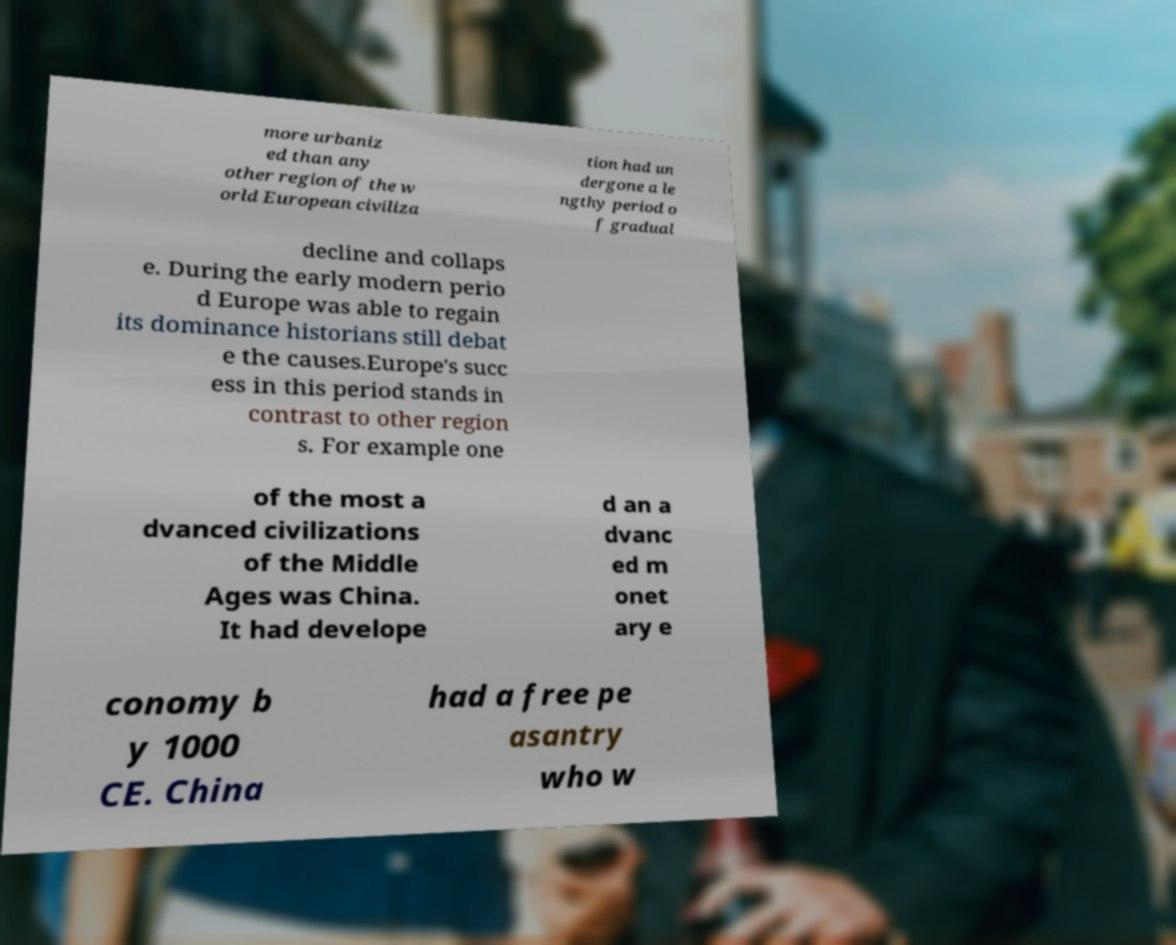Can you read and provide the text displayed in the image?This photo seems to have some interesting text. Can you extract and type it out for me? more urbaniz ed than any other region of the w orld European civiliza tion had un dergone a le ngthy period o f gradual decline and collaps e. During the early modern perio d Europe was able to regain its dominance historians still debat e the causes.Europe's succ ess in this period stands in contrast to other region s. For example one of the most a dvanced civilizations of the Middle Ages was China. It had develope d an a dvanc ed m onet ary e conomy b y 1000 CE. China had a free pe asantry who w 